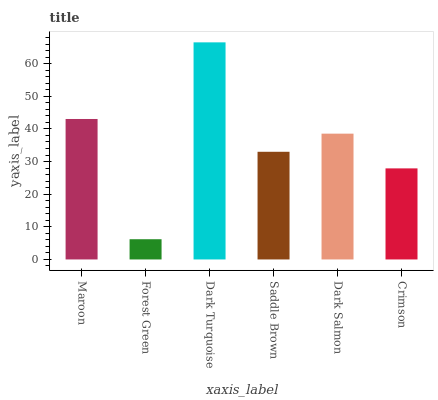Is Dark Turquoise the maximum?
Answer yes or no. Yes. Is Dark Turquoise the minimum?
Answer yes or no. No. Is Forest Green the maximum?
Answer yes or no. No. Is Dark Turquoise greater than Forest Green?
Answer yes or no. Yes. Is Forest Green less than Dark Turquoise?
Answer yes or no. Yes. Is Forest Green greater than Dark Turquoise?
Answer yes or no. No. Is Dark Turquoise less than Forest Green?
Answer yes or no. No. Is Dark Salmon the high median?
Answer yes or no. Yes. Is Saddle Brown the low median?
Answer yes or no. Yes. Is Saddle Brown the high median?
Answer yes or no. No. Is Maroon the low median?
Answer yes or no. No. 